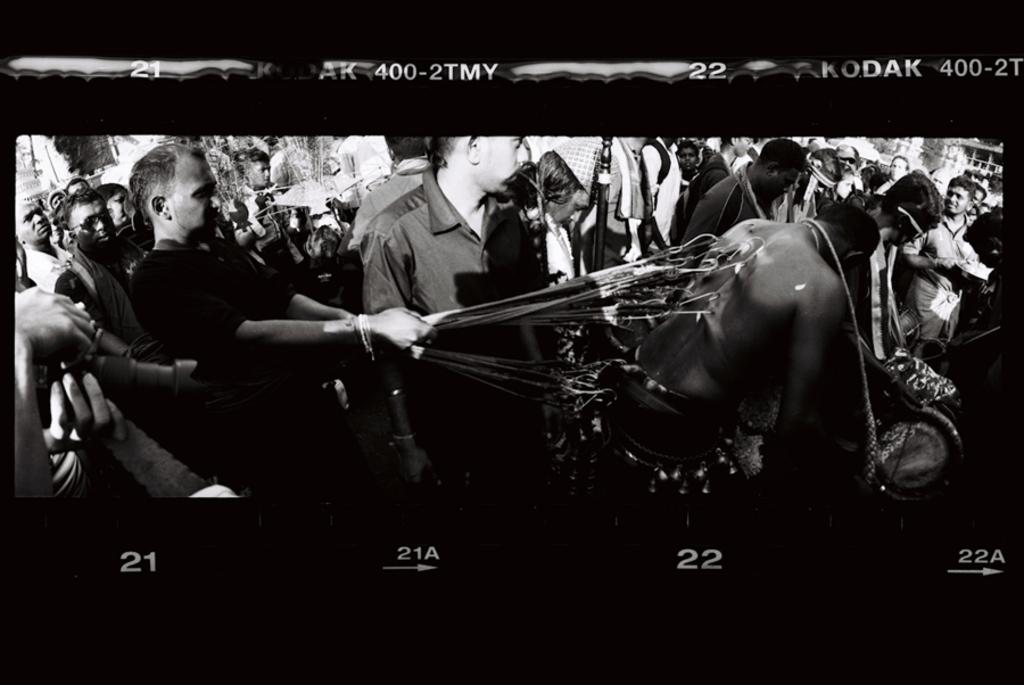What is happening in the image involving the people? Some people are being beaten with a sharp iron tool. How many people are present in the image? The number of people cannot be determined from the provided facts. What is the color scheme of the image? The image is in black and white color. What type of cakes are being served in the image? There is no mention of cakes or any food items in the provided facts. Can you hear a bell ringing in the image? The provided facts do not mention any sound or audio elements. 